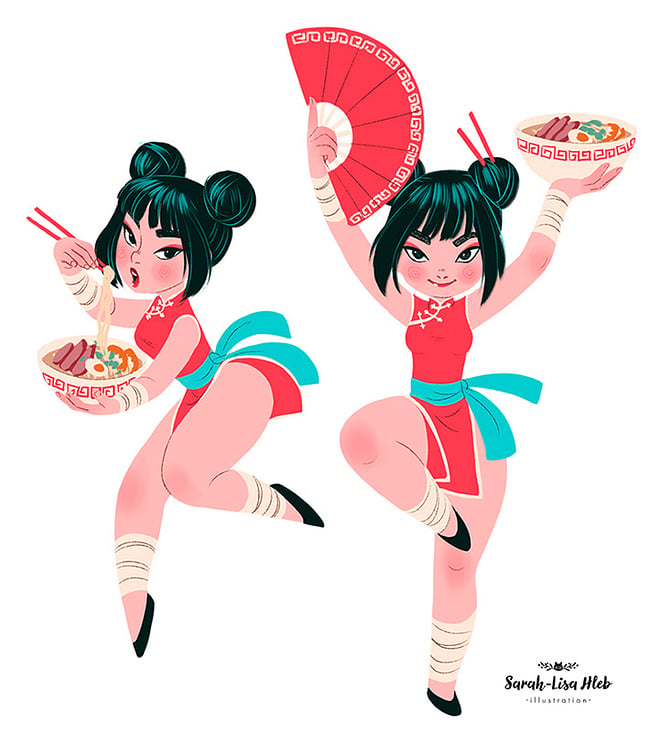Describe the expressions and body language of the characters, and interpret how these might reflect the illustrator's message. The characters display expressions of joy and confidence, with energetic and poised body language that conveys a sense of motion and liveliness. Such portrayals may suggest the illustrator's intent to represent cultural pride and the empowerment of merging traditional and contemporary elements. Their upbeat and vibrant demeanor can be seen as an invitation to appreciate and engage with the cultural fusion being presented, encapsulating a message of harmony and innovation in cultural expression. 